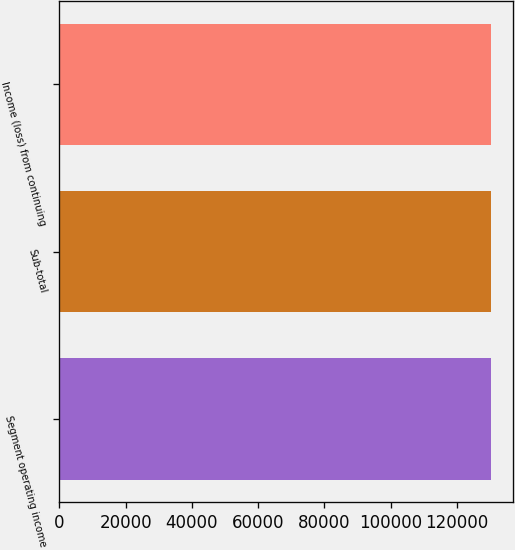<chart> <loc_0><loc_0><loc_500><loc_500><bar_chart><fcel>Segment operating income<fcel>Sub-total<fcel>Income (loss) from continuing<nl><fcel>130280<fcel>130280<fcel>130280<nl></chart> 